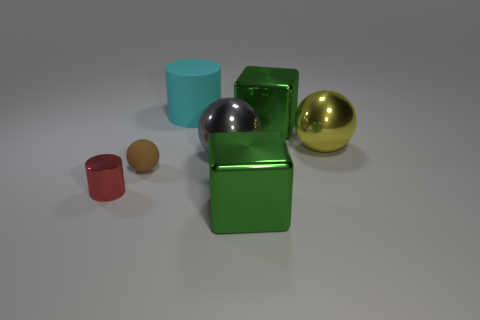Add 2 small brown rubber balls. How many objects exist? 9 Subtract all balls. How many objects are left? 4 Subtract all red cylinders. Subtract all brown matte things. How many objects are left? 5 Add 1 brown matte objects. How many brown matte objects are left? 2 Add 7 big red shiny cubes. How many big red shiny cubes exist? 7 Subtract 0 yellow cylinders. How many objects are left? 7 